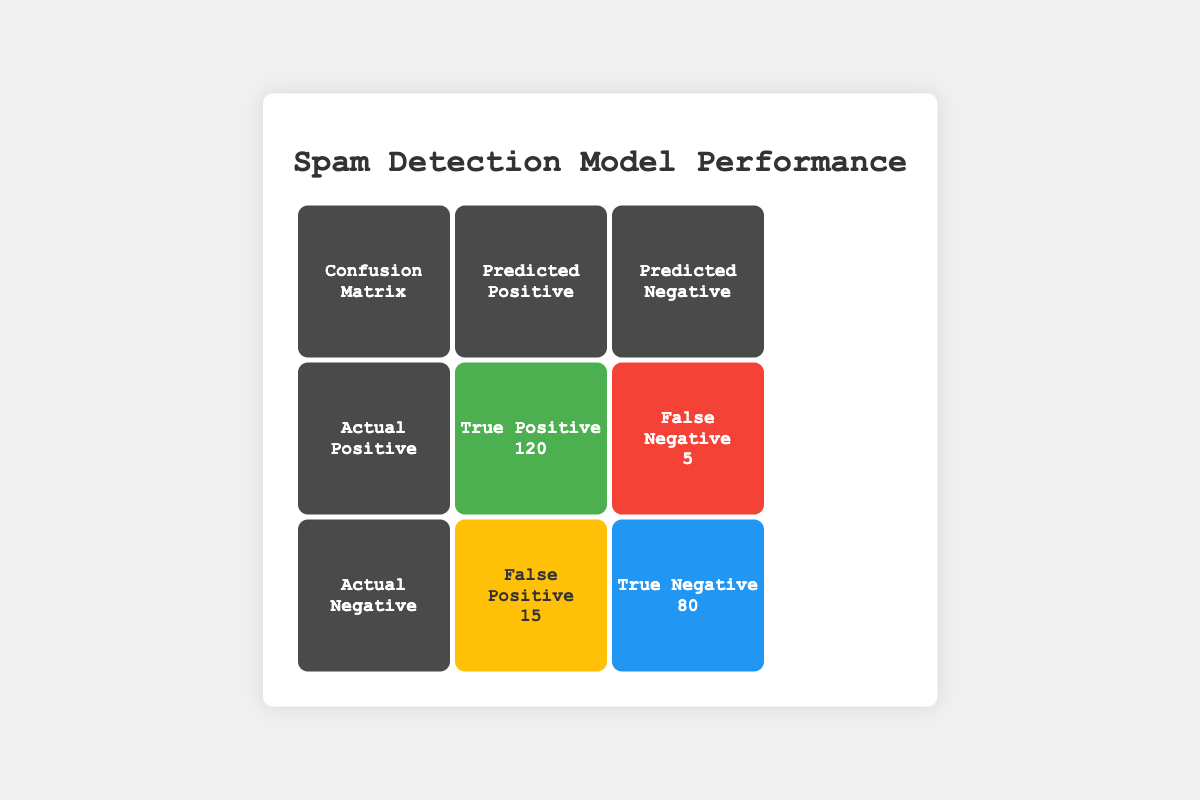What is the number of True Positives in the model? The table indicates that True Positives, which represent the correctly identified spam messages, are listed under "True Positive" and the value is given as 120.
Answer: 120 What is the total number of instances where the model predicted spam? To find the total number of instances where the model predicted spam, we add True Positives (120) and False Positives (15). Thus, the calculation is 120 + 15 = 135.
Answer: 135 How many actual spam messages were incorrectly identified as not spam? The table shows that 5 instances were classified as False Negatives, which means these actual spam messages were incorrectly identified as not spam.
Answer: 5 What percentage of actual spam messages were correctly identified as spam? To find the percentage of actual spam messages correctly identified, we use True Positives (120) over the total actual positives, which is the sum of True Positives and False Negatives (120 + 5 = 125). The percentage is calculated as (120 / 125) * 100 = 96%.
Answer: 96% Is the number of True Negatives greater than the number of False Positives? The table shows that True Negatives are 80 and False Positives are 15. Since 80 is greater than 15, the answer is yes, True Negatives are greater than False Positives.
Answer: Yes What is the overall accuracy of the spam detection model? Overall accuracy is calculated by taking the sum of True Positives and True Negatives and dividing by the total number of instances. Total instances is the sum of all components: True Positive (120) + True Negative (80) + False Positive (15) + False Negative (5) = 220. Thus, accuracy = (120 + 80) / 220 = 200/220 = approximately 0.909 or 90.9%.
Answer: 90.9% How many instances were misclassified by the model? Instances misclassified include both False Positives and False Negatives. Therefore, we sum these values: False Positives (15) + False Negatives (5) = 20 instances misclassified.
Answer: 20 What is the ratio of True Positives to False Negatives? The ratio of True Positives to False Negatives can be calculated by dividing True Positives (120) by False Negatives (5). Thus, the ratio is 120 / 5 = 24.
Answer: 24 How many instances were correctly classified as not spam? The number of correctly classified instances as not spam is equal to the True Negatives, which is listed as 80 in the table.
Answer: 80 